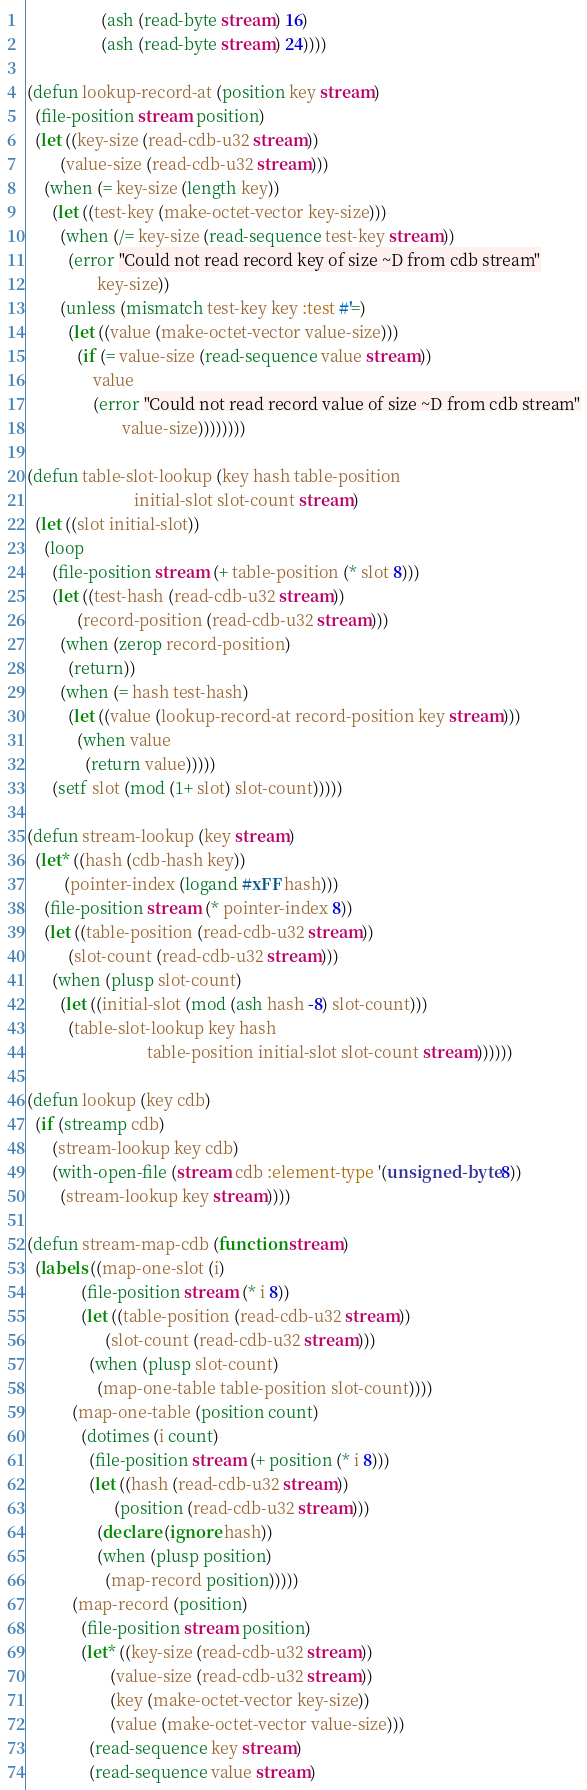Convert code to text. <code><loc_0><loc_0><loc_500><loc_500><_Lisp_>                  (ash (read-byte stream) 16)
                  (ash (read-byte stream) 24))))

(defun lookup-record-at (position key stream)
  (file-position stream position)
  (let ((key-size (read-cdb-u32 stream))
        (value-size (read-cdb-u32 stream)))
    (when (= key-size (length key))
      (let ((test-key (make-octet-vector key-size)))
        (when (/= key-size (read-sequence test-key stream))
          (error "Could not read record key of size ~D from cdb stream"
                 key-size))
        (unless (mismatch test-key key :test #'=)
          (let ((value (make-octet-vector value-size)))
            (if (= value-size (read-sequence value stream))
                value
                (error "Could not read record value of size ~D from cdb stream"
                       value-size))))))))

(defun table-slot-lookup (key hash table-position
                          initial-slot slot-count stream)
  (let ((slot initial-slot))
    (loop
      (file-position stream (+ table-position (* slot 8)))
      (let ((test-hash (read-cdb-u32 stream))
            (record-position (read-cdb-u32 stream)))
        (when (zerop record-position)
          (return))
        (when (= hash test-hash)
          (let ((value (lookup-record-at record-position key stream)))
            (when value
              (return value)))))
      (setf slot (mod (1+ slot) slot-count)))))

(defun stream-lookup (key stream)
  (let* ((hash (cdb-hash key))
         (pointer-index (logand #xFF hash)))
    (file-position stream (* pointer-index 8))
    (let ((table-position (read-cdb-u32 stream))
          (slot-count (read-cdb-u32 stream)))
      (when (plusp slot-count)
        (let ((initial-slot (mod (ash hash -8) slot-count)))
          (table-slot-lookup key hash
                             table-position initial-slot slot-count stream))))))

(defun lookup (key cdb)
  (if (streamp cdb)
      (stream-lookup key cdb)
      (with-open-file (stream cdb :element-type '(unsigned-byte 8))
        (stream-lookup key stream))))

(defun stream-map-cdb (function stream)
  (labels ((map-one-slot (i)
             (file-position stream (* i 8))
             (let ((table-position (read-cdb-u32 stream))
                   (slot-count (read-cdb-u32 stream)))
               (when (plusp slot-count)
                 (map-one-table table-position slot-count))))
           (map-one-table (position count)
             (dotimes (i count)
               (file-position stream (+ position (* i 8)))
               (let ((hash (read-cdb-u32 stream))
                     (position (read-cdb-u32 stream)))
                 (declare (ignore hash))
                 (when (plusp position)
                   (map-record position)))))
           (map-record (position)
             (file-position stream position)
             (let* ((key-size (read-cdb-u32 stream))
                    (value-size (read-cdb-u32 stream))
                    (key (make-octet-vector key-size))
                    (value (make-octet-vector value-size)))
               (read-sequence key stream)
               (read-sequence value stream)</code> 